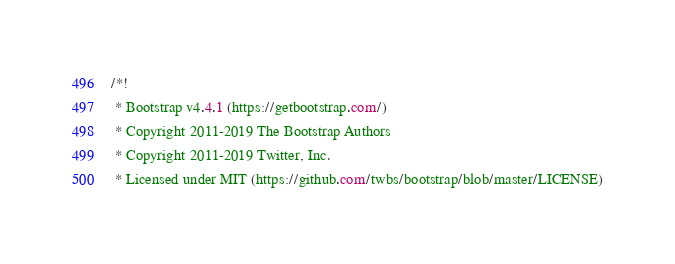<code> <loc_0><loc_0><loc_500><loc_500><_CSS_>/*!
 * Bootstrap v4.4.1 (https://getbootstrap.com/)
 * Copyright 2011-2019 The Bootstrap Authors
 * Copyright 2011-2019 Twitter, Inc.
 * Licensed under MIT (https://github.com/twbs/bootstrap/blob/master/LICENSE)</code> 